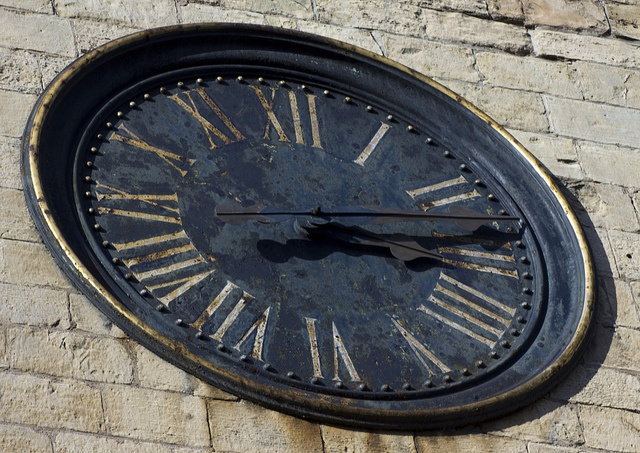Describe the objects in this image and their specific colors. I can see a clock in darkgray, black, gray, and darkblue tones in this image. 